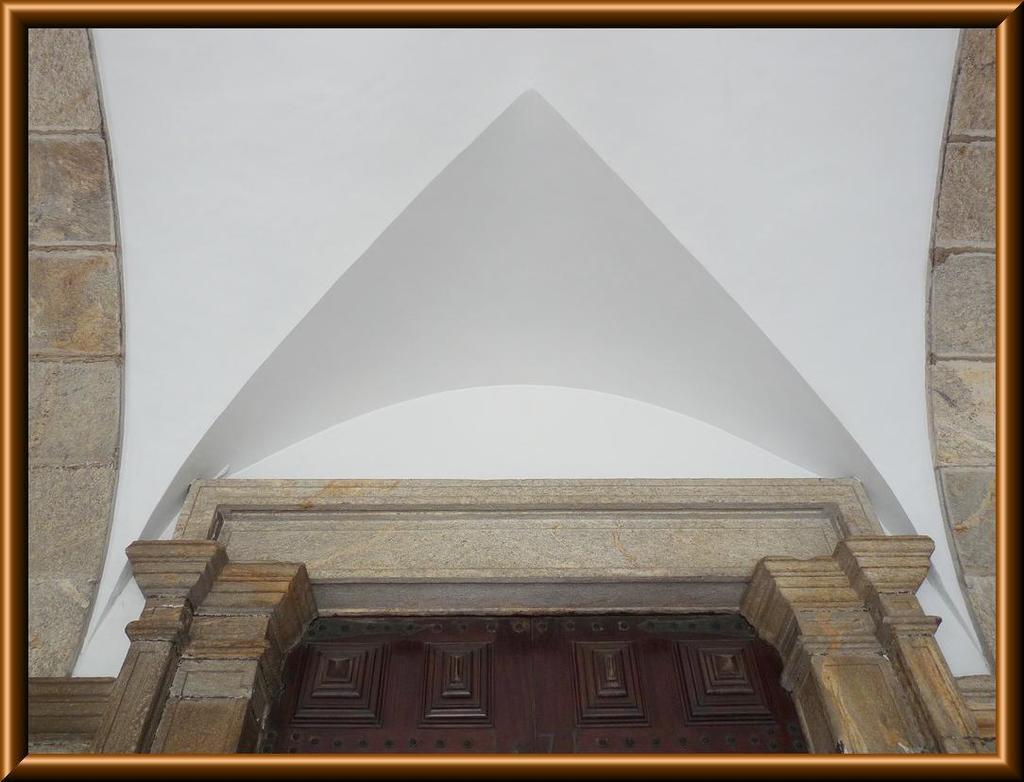How would you summarize this image in a sentence or two? In this picture we can see a frame of a building. 